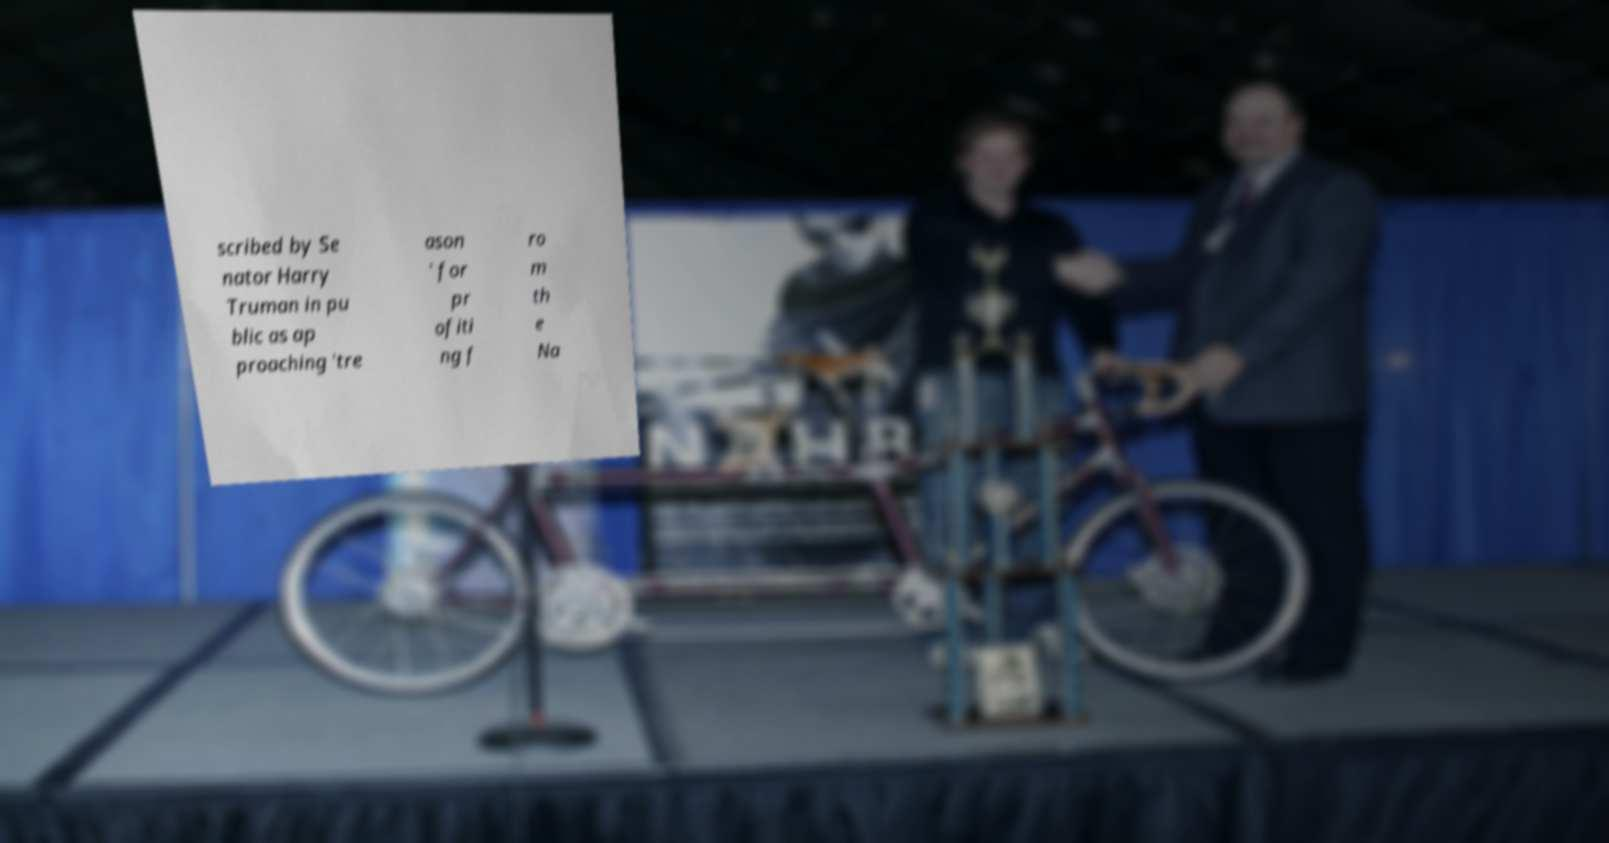Please read and relay the text visible in this image. What does it say? scribed by Se nator Harry Truman in pu blic as ap proaching 'tre ason ' for pr ofiti ng f ro m th e Na 